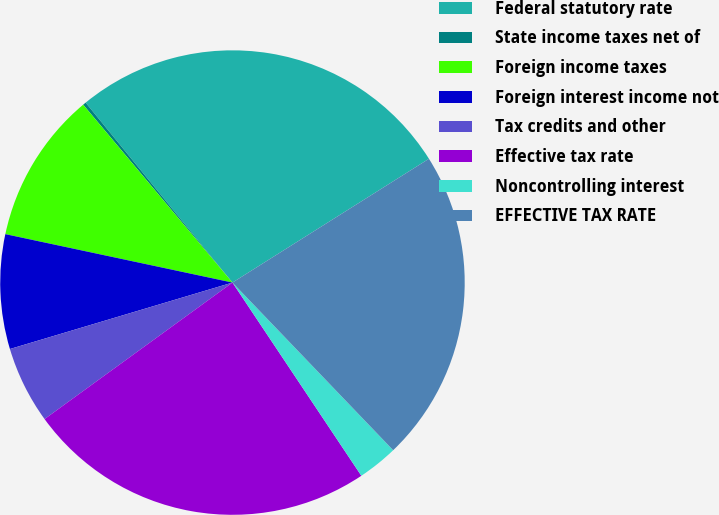<chart> <loc_0><loc_0><loc_500><loc_500><pie_chart><fcel>Federal statutory rate<fcel>State income taxes net of<fcel>Foreign income taxes<fcel>Foreign interest income not<fcel>Tax credits and other<fcel>Effective tax rate<fcel>Noncontrolling interest<fcel>EFFECTIVE TAX RATE<nl><fcel>26.94%<fcel>0.22%<fcel>10.54%<fcel>7.96%<fcel>5.38%<fcel>24.36%<fcel>2.8%<fcel>21.78%<nl></chart> 